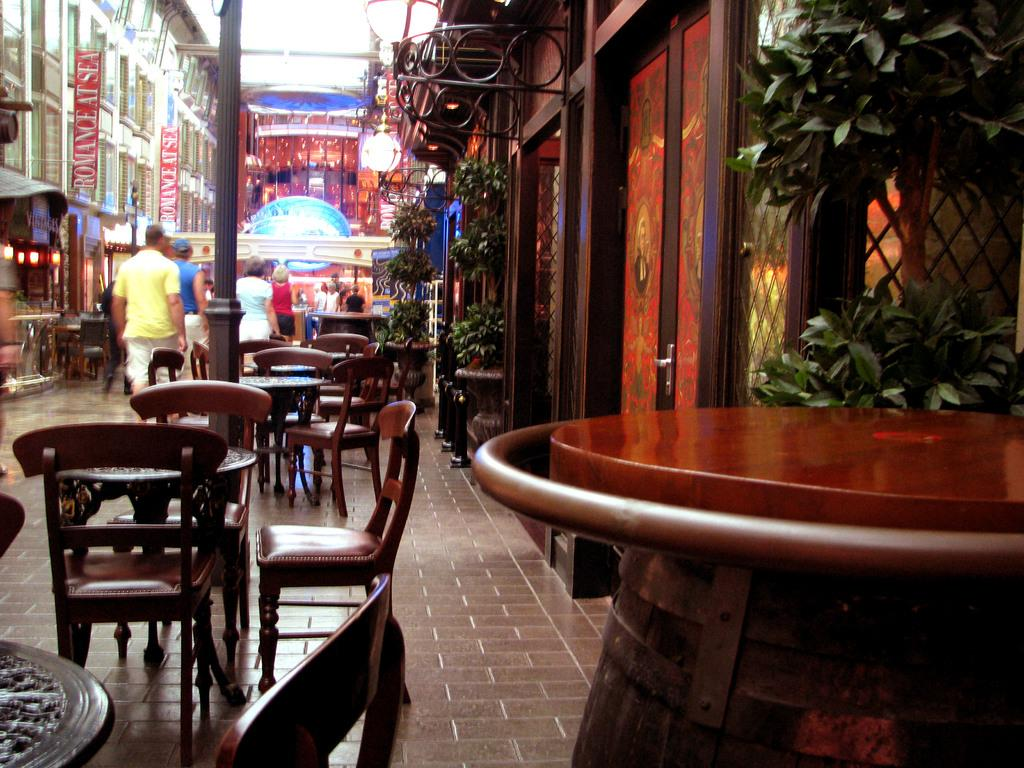Who or what can be seen in the image? There are people in the image. What furniture is present in the image? There are chairs and tables in the image. What type of structures are visible in the image? There are buildings in the image. What natural elements are present in the image? There are plants in the image. What type of illumination is present in the image? There are lights in the image. What type of decorations are present in the image? There are posters in the image. What other objects can be seen in the image? There are some objects in the image. What type of lumber is being used to construct the buildings in the image? There is no specific information about the type of lumber used in the construction of the buildings in the image. What type of crime is being committed in the image? There is no indication of any crime being committed in the image. 